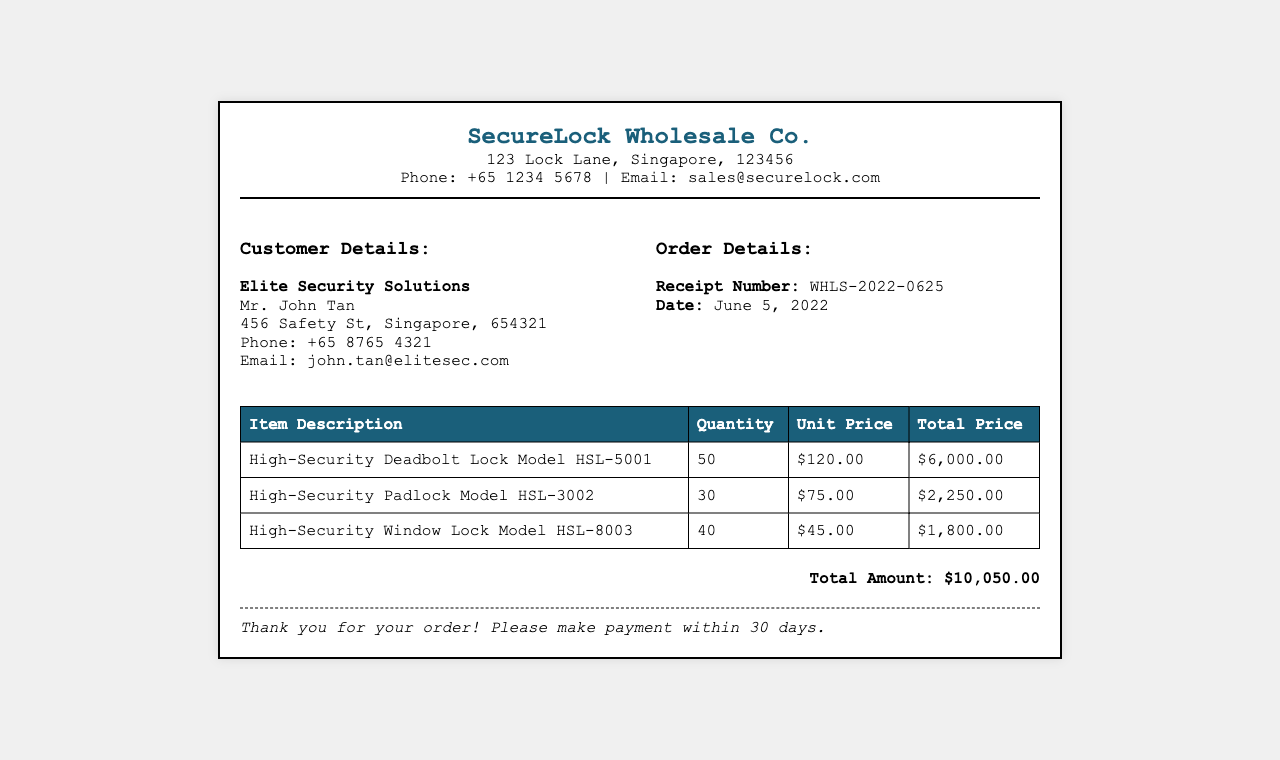What is the company name? The company name is located in the header section of the receipt.
Answer: SecureLock Wholesale Co What is the receipt number? The receipt number is specified under the order details in the document.
Answer: WHLS-2022-0625 When was the order placed? The order date is mentioned in the order details section of the receipt.
Answer: June 5, 2022 What is the total amount for the order? The total amount is found at the bottom of the receipt in the total section.
Answer: $10,050.00 How many High-Security Deadbolt Locks were ordered? The quantity is listed in the table under the appropriate item description.
Answer: 50 What is the unit price of the High-Security Padlock Model HSL-3002? The unit price can be found in the table corresponding to the item description.
Answer: $75.00 Which customer placed the order? The customer's name is mentioned in the customer details section of the receipt.
Answer: Elite Security Solutions What is the quantity of High-Security Window Locks? The quantity is specified in the corresponding row of the table.
Answer: 40 How many items are listed in the receipt? The item count is determined by counting the rows in the item table.
Answer: 3 